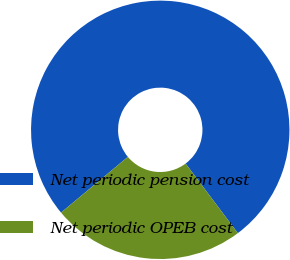Convert chart. <chart><loc_0><loc_0><loc_500><loc_500><pie_chart><fcel>Net periodic pension cost<fcel>Net periodic OPEB cost<nl><fcel>75.82%<fcel>24.18%<nl></chart> 